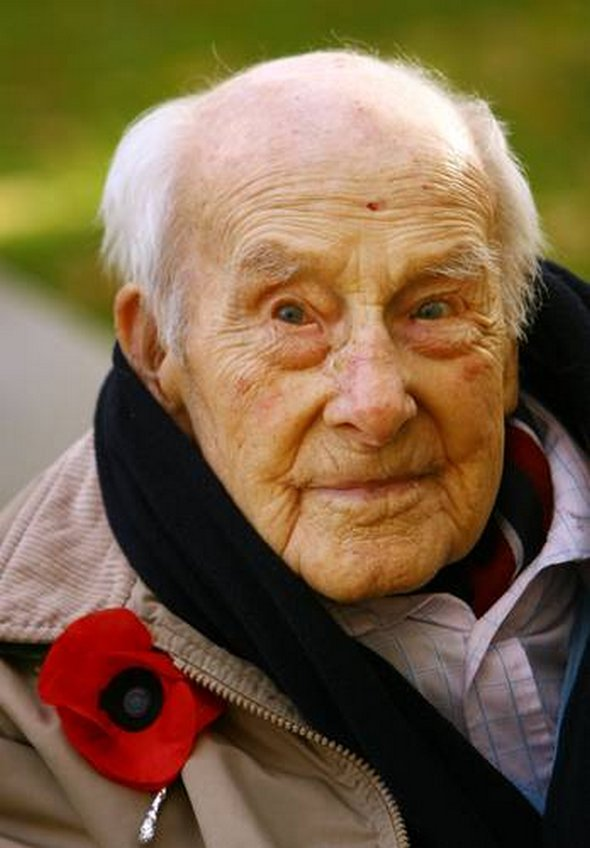Considering the man’s attire and the poppy flower, what time of the year or event could this image have been taken around? The red poppy flower is a significant symbol often associated with Remembrance Day, also known as Poppy Day. This day is commemorated on November 11th in many Commonwealth member states to honor military personnel who have died in the line of duty since World War I. The man's attire, including a jacket and scarf, suggests cooler weather, typical of autumn or early winter. This clothing choice, combined with the presence of the poppy, strongly indicates that the image could have been taken around Remembrance Day, which falls in November. Therefore, it is likely that this image was captured around November 11th during the commemorative events of Remembrance Day. 